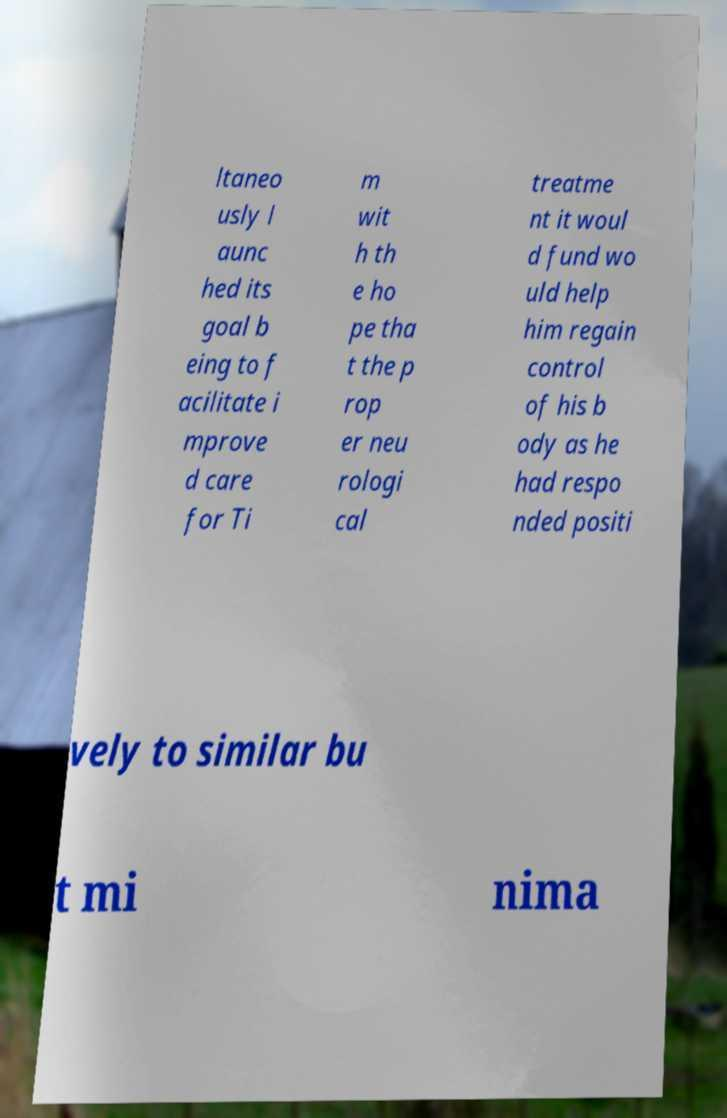Please read and relay the text visible in this image. What does it say? ltaneo usly l aunc hed its goal b eing to f acilitate i mprove d care for Ti m wit h th e ho pe tha t the p rop er neu rologi cal treatme nt it woul d fund wo uld help him regain control of his b ody as he had respo nded positi vely to similar bu t mi nima 